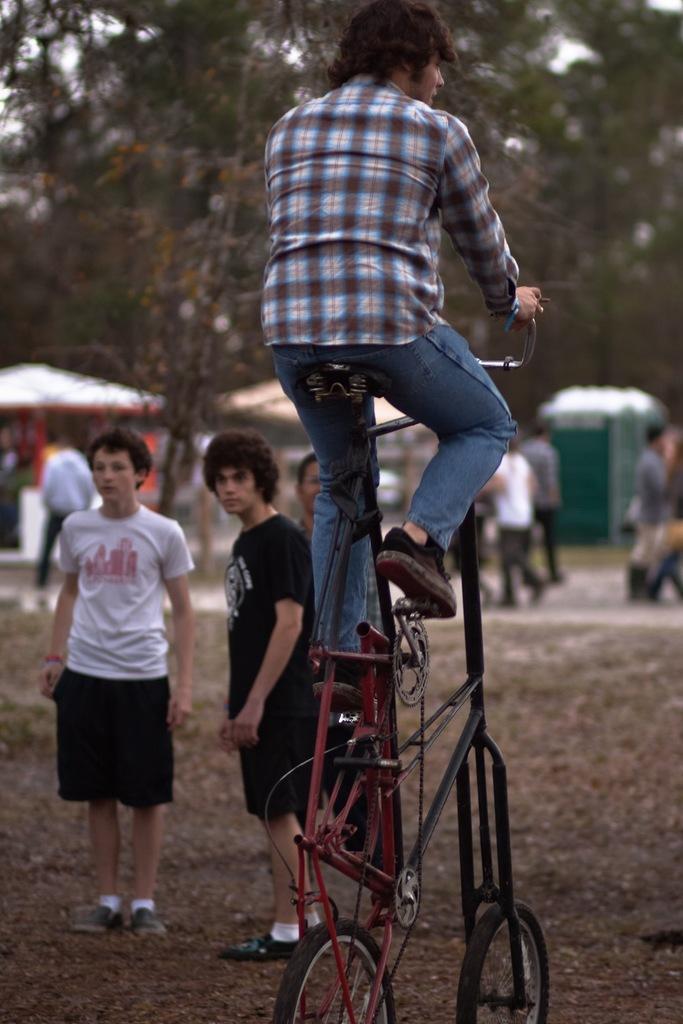What is the man in the image doing? The man in the image is riding a bicycle. Are there any other people in the image besides the man on the bicycle? Yes, there are people walking behind the man on the bicycle. Where are the men located in the image? The men are standing at the bottom left side of the image. What can be seen at the top of the image? There are trees visible at the top of the image. What type of stem can be seen growing from the man's head in the image? There is no stem growing from the man's head in the image. Can you describe the kitty playing with a ball of yarn in the image? There is no kitty or ball of yarn present in the image. 